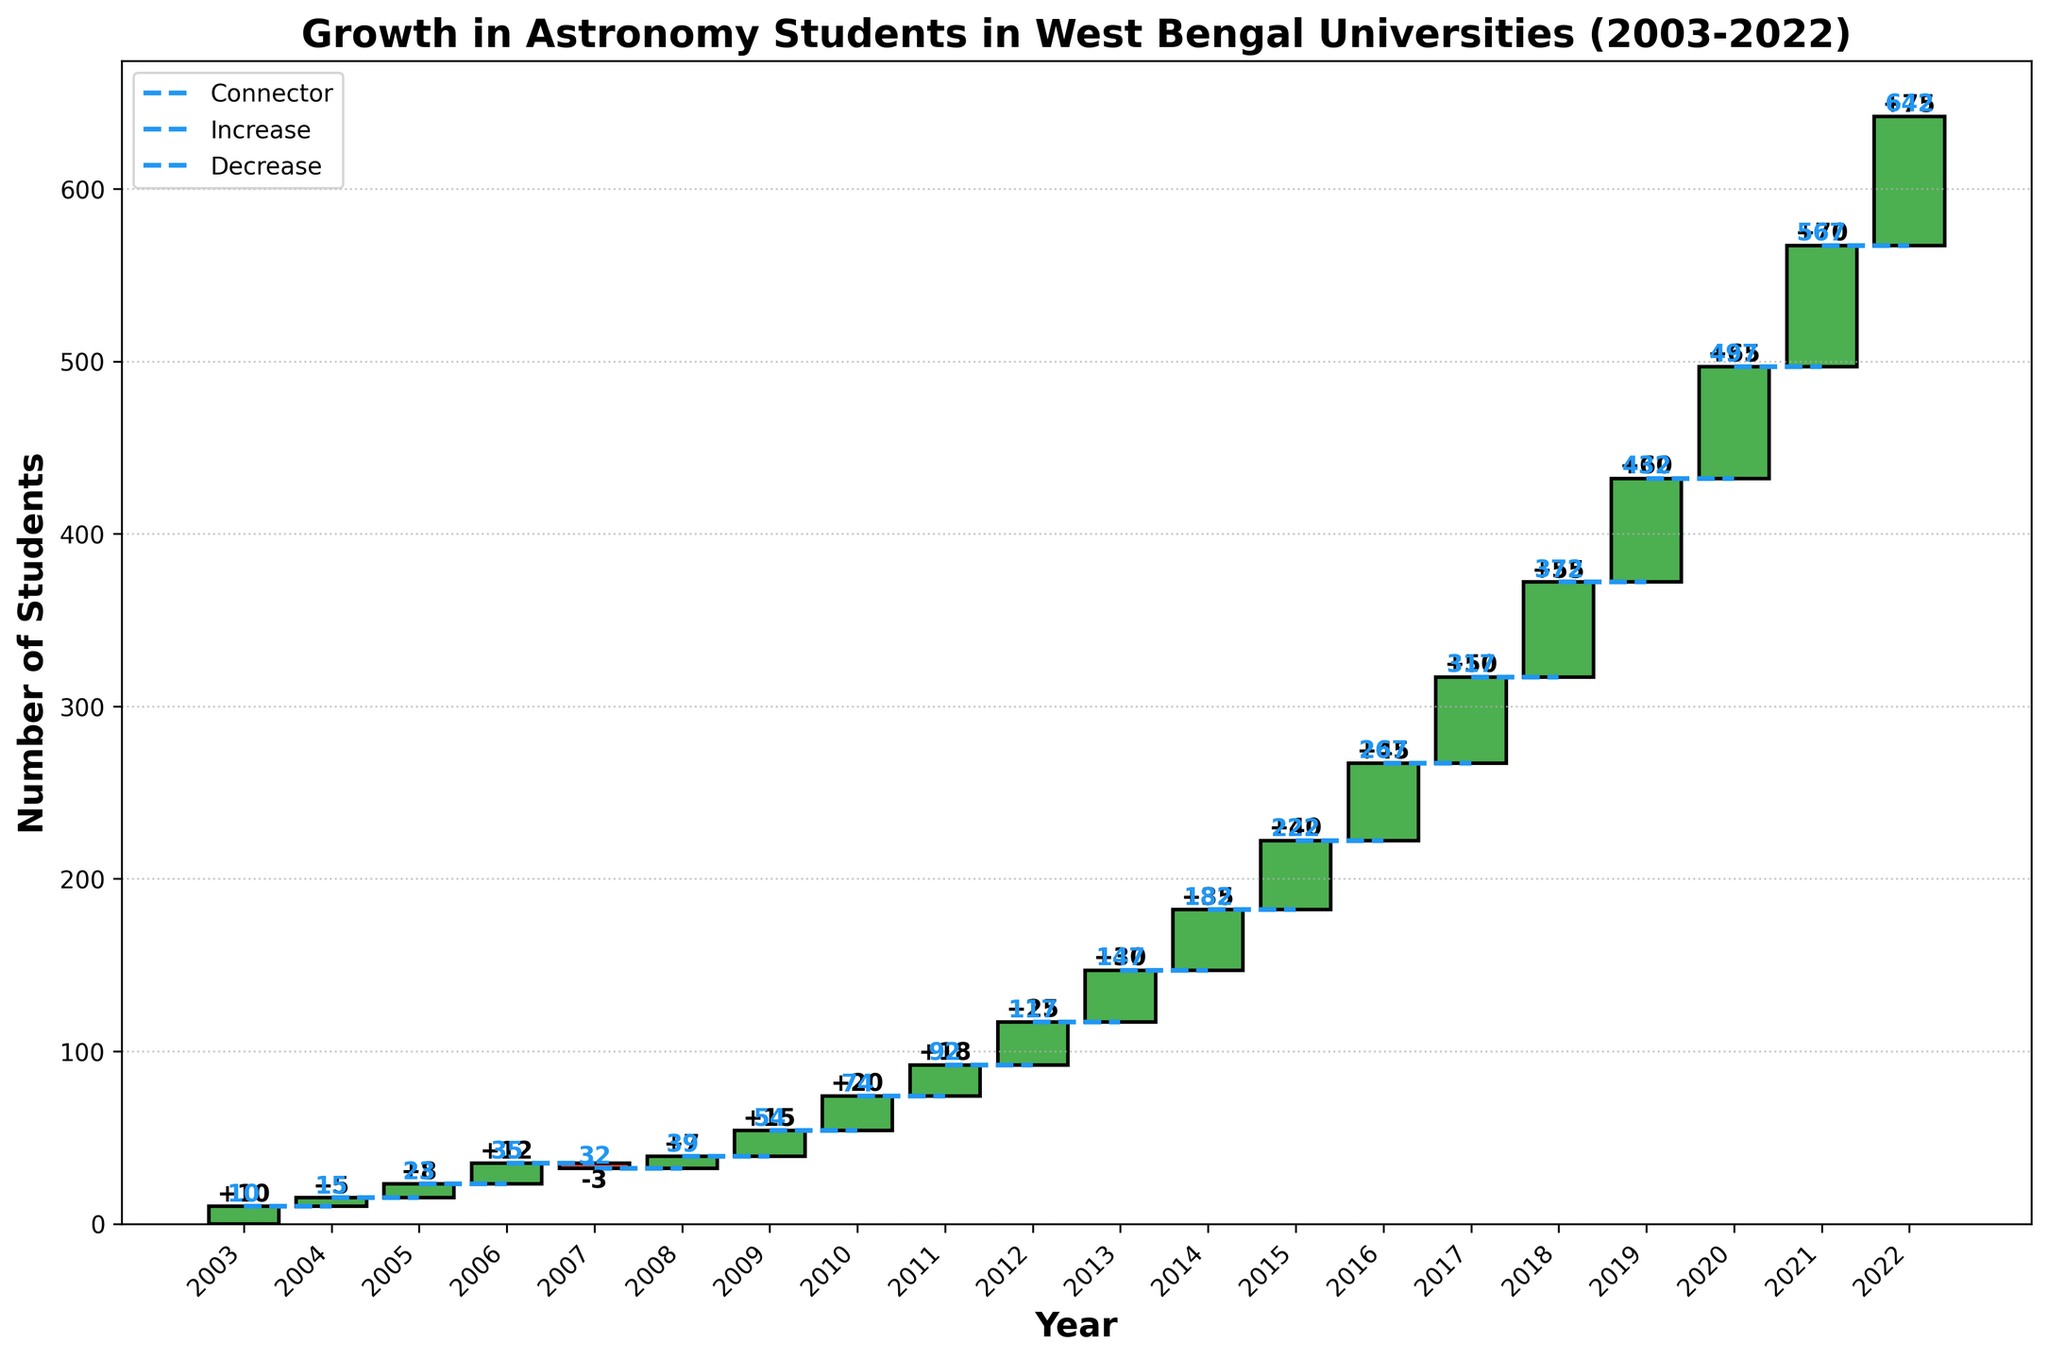What's the title of the chart? The title of the chart is displayed at the top, which reads "Growth in Astronomy Students in West Bengal Universities (2003-2022)"
Answer: Growth in Astronomy Students in West Bengal Universities (2003-2022) How many years does the chart cover? The x-axis indicates the span of time covered by the chart. The first year is indicated as 2003 and the last year as 2022.
Answer: 20 years In which year was there a decrease in the number of students? The bars on the chart that show a negative value indicate a decrease. In 2007, the bar is red, showing a value of -3.
Answer: 2007 What was the total number of students pursuing astronomy degrees in 2015? The running total for each year is shown on the top of the bars. For 2015, the running total is located at the top of the corresponding bar and it reads 222.
Answer: 222 By how much did the number of students increase in 2010? The value inside each bar represents the change in that year. In 2010, the bar shows an increase of 20.
Answer: 20 Which year had the highest single-year increase in the number of students? By comparing the values inside each bar, the highest single-year increase is found by identifying the largest positive value. In 2022, the increase was 75.
Answer: 2022 What is the lowest running total shown in the chart? The running total values displayed above each bar help identify the smallest one. The lowest running total is found in the first year, 2003, which is 10.
Answer: 10 What was the total number of students pursuing astronomy degrees by 2022? This information is shown by the running total at the top of the bar for the year 2022, which reads 642.
Answer: 642 What is the average annual increase in the number of students from 2010 to 2022? Calculate the difference between the running totals in 2010 and 2022 to get the total increase: 642 - 74 = 568. Then, divide this by the number of years between 2010 and 2022, which is 12: 568 / 12 = 47.33
Answer: 47.33 Compare the increases in 2004 and 2019. Which year had a higher increase? In 2004, the increase was 5. In 2019, the increase was 60. Comparing these two values, 2019 had a higher increase.
Answer: 2019 